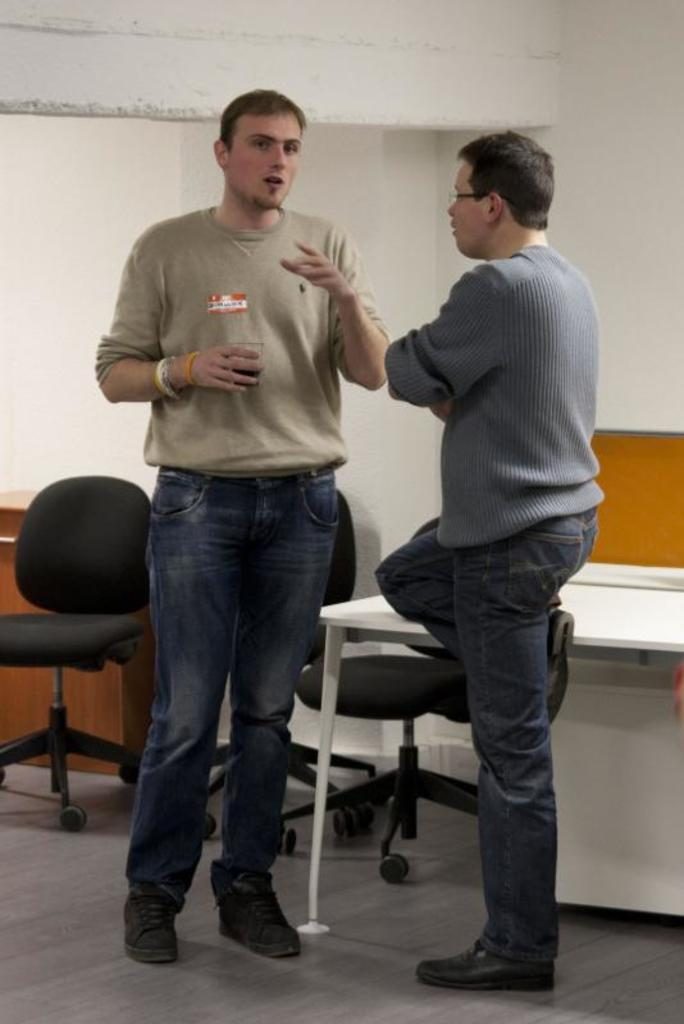How many people are in the image? There are two people in the image. What are the two people doing in the image? The two people are standing on the floor, and one of them is talking to the other. Can you describe the actions of one of the people in the image? One of the people is holding a drink in his hand. What type of furniture is visible in the image? There are chairs visible in the image. What type of substance is the goat chewing on in the image? There is no goat present in the image, so it is not possible to answer that question. 